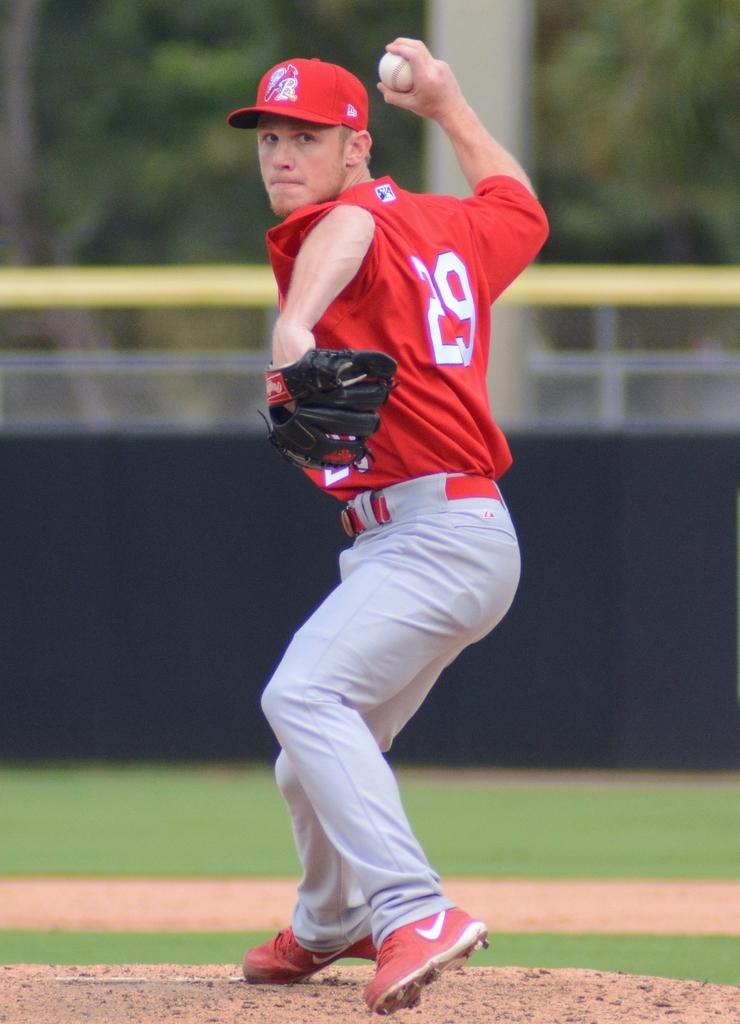What is the main subject of the image? The main subject of the image is a man. What is the man wearing on his upper body? The man is wearing a red T-shirt. What is the man wearing on his lower body? The man is wearing grey pants. What is the man wearing on his feet? The man is wearing red shoes. What is the man wearing on his head? The man is wearing a red cap. What object is the man holding in his hand? The man is holding a ball in his hand. How would you describe the background of the image? The background of the image is blurred. What statement does the man make in the image? There is no statement made by the man in the image, as it is a still photograph. What knowledge does the man possess about riddles in the image? There is no indication of the man's knowledge about riddles in the image. 